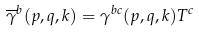<formula> <loc_0><loc_0><loc_500><loc_500>\overline { \gamma } ^ { b } ( p , q , k ) = \gamma ^ { b c } ( p , q , k ) T ^ { c }</formula> 